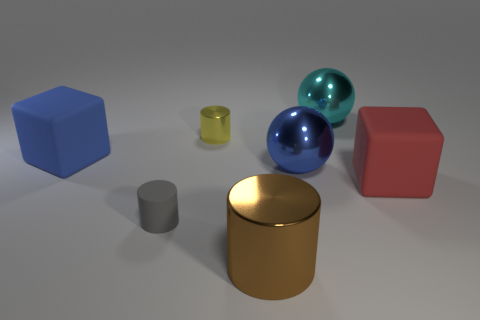Add 1 brown matte things. How many objects exist? 8 Subtract all balls. How many objects are left? 5 Subtract all tiny metal things. Subtract all brown shiny objects. How many objects are left? 5 Add 1 large blue rubber blocks. How many large blue rubber blocks are left? 2 Add 1 purple matte cylinders. How many purple matte cylinders exist? 1 Subtract 0 purple blocks. How many objects are left? 7 